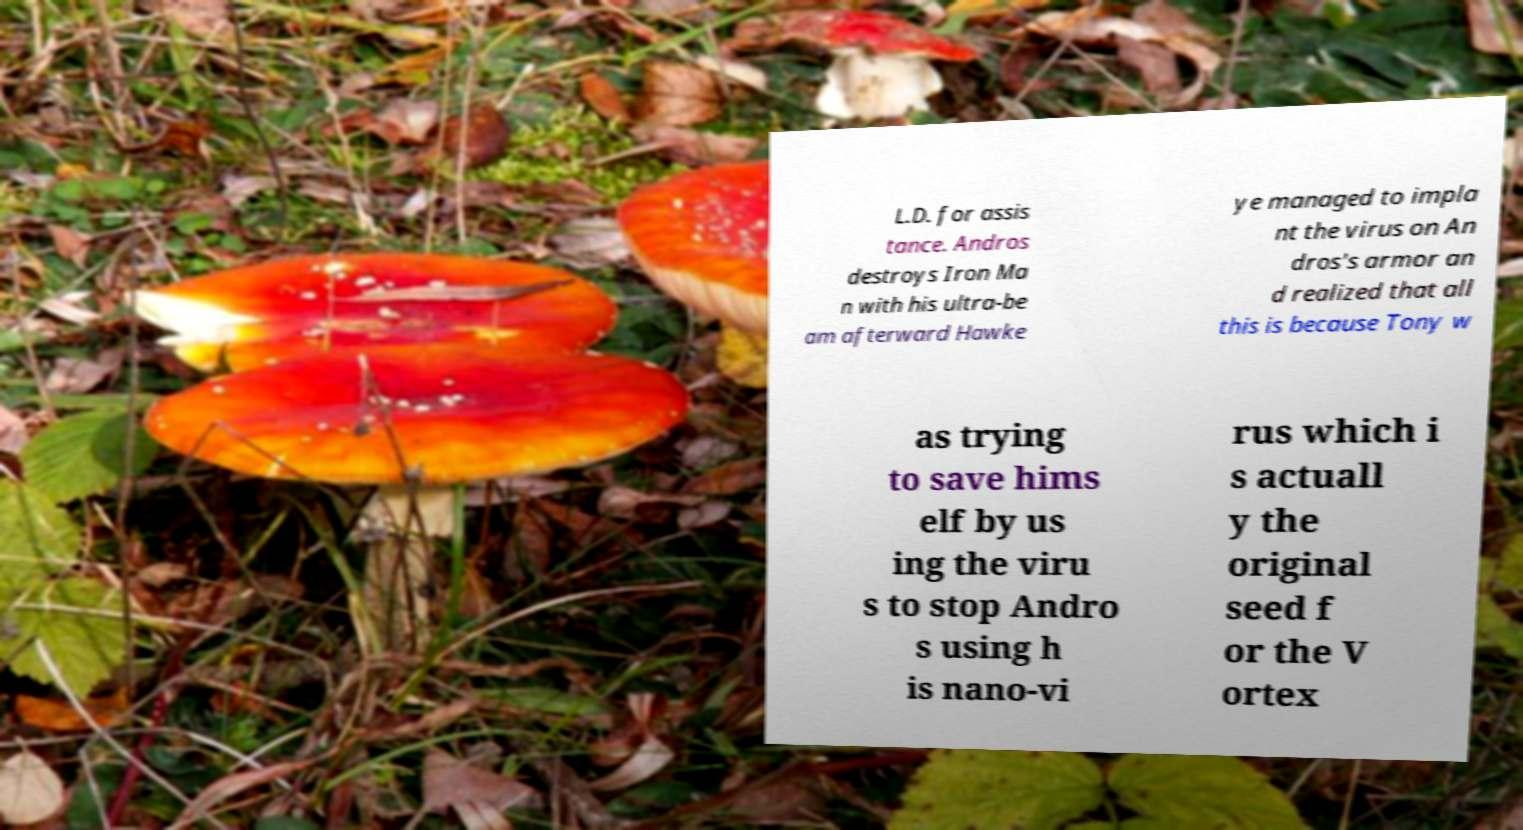Can you accurately transcribe the text from the provided image for me? L.D. for assis tance. Andros destroys Iron Ma n with his ultra-be am afterward Hawke ye managed to impla nt the virus on An dros's armor an d realized that all this is because Tony w as trying to save hims elf by us ing the viru s to stop Andro s using h is nano-vi rus which i s actuall y the original seed f or the V ortex 